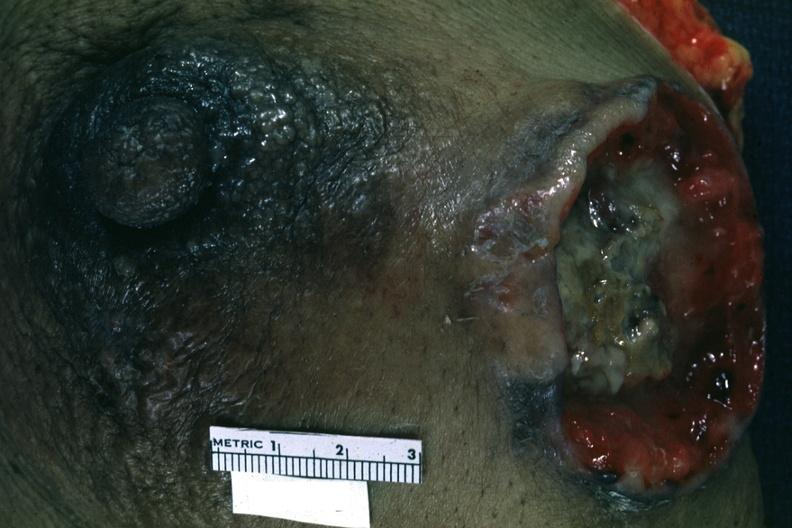what excised breast with large ulcerating carcinoma?
Answer the question using a single word or phrase. Close-up 